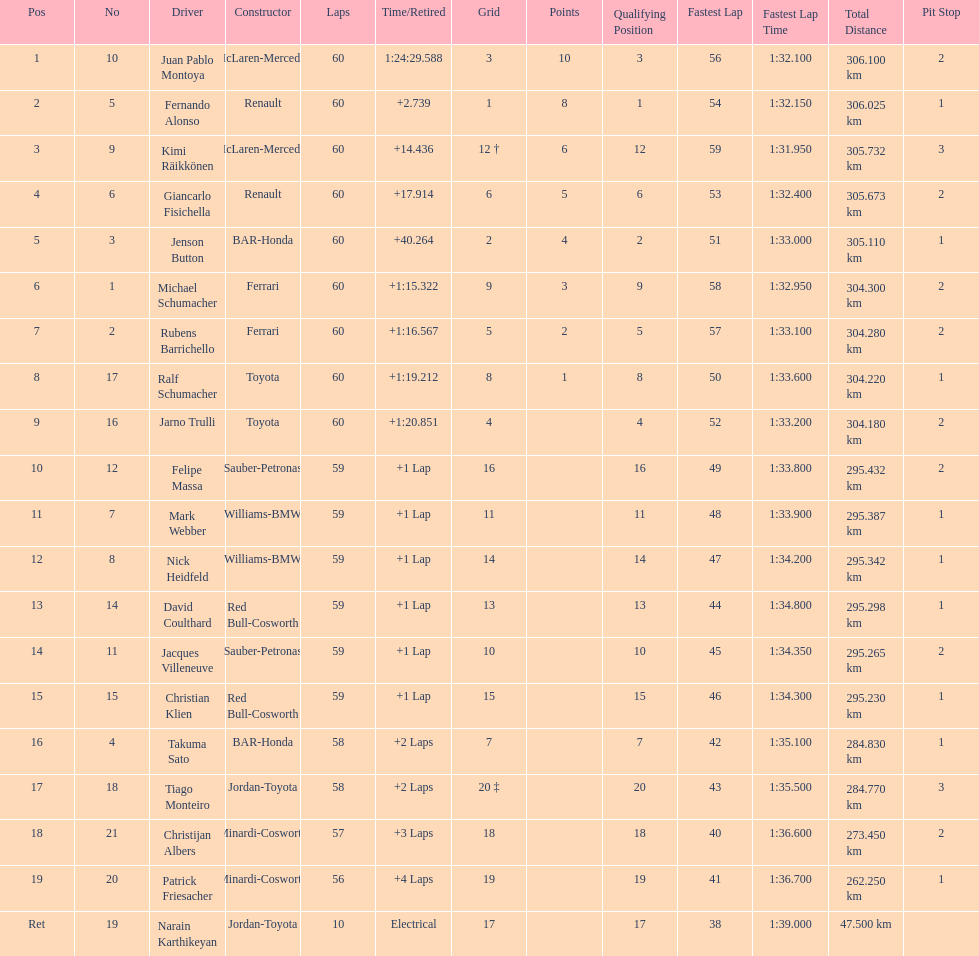Which driver has the least amount of points? Ralf Schumacher. 